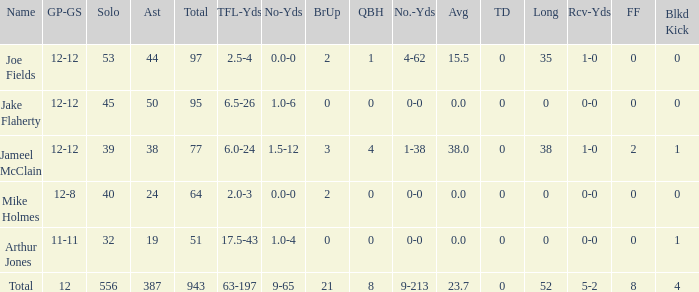How many yards does the player have with tfl-yds of 4-62. 